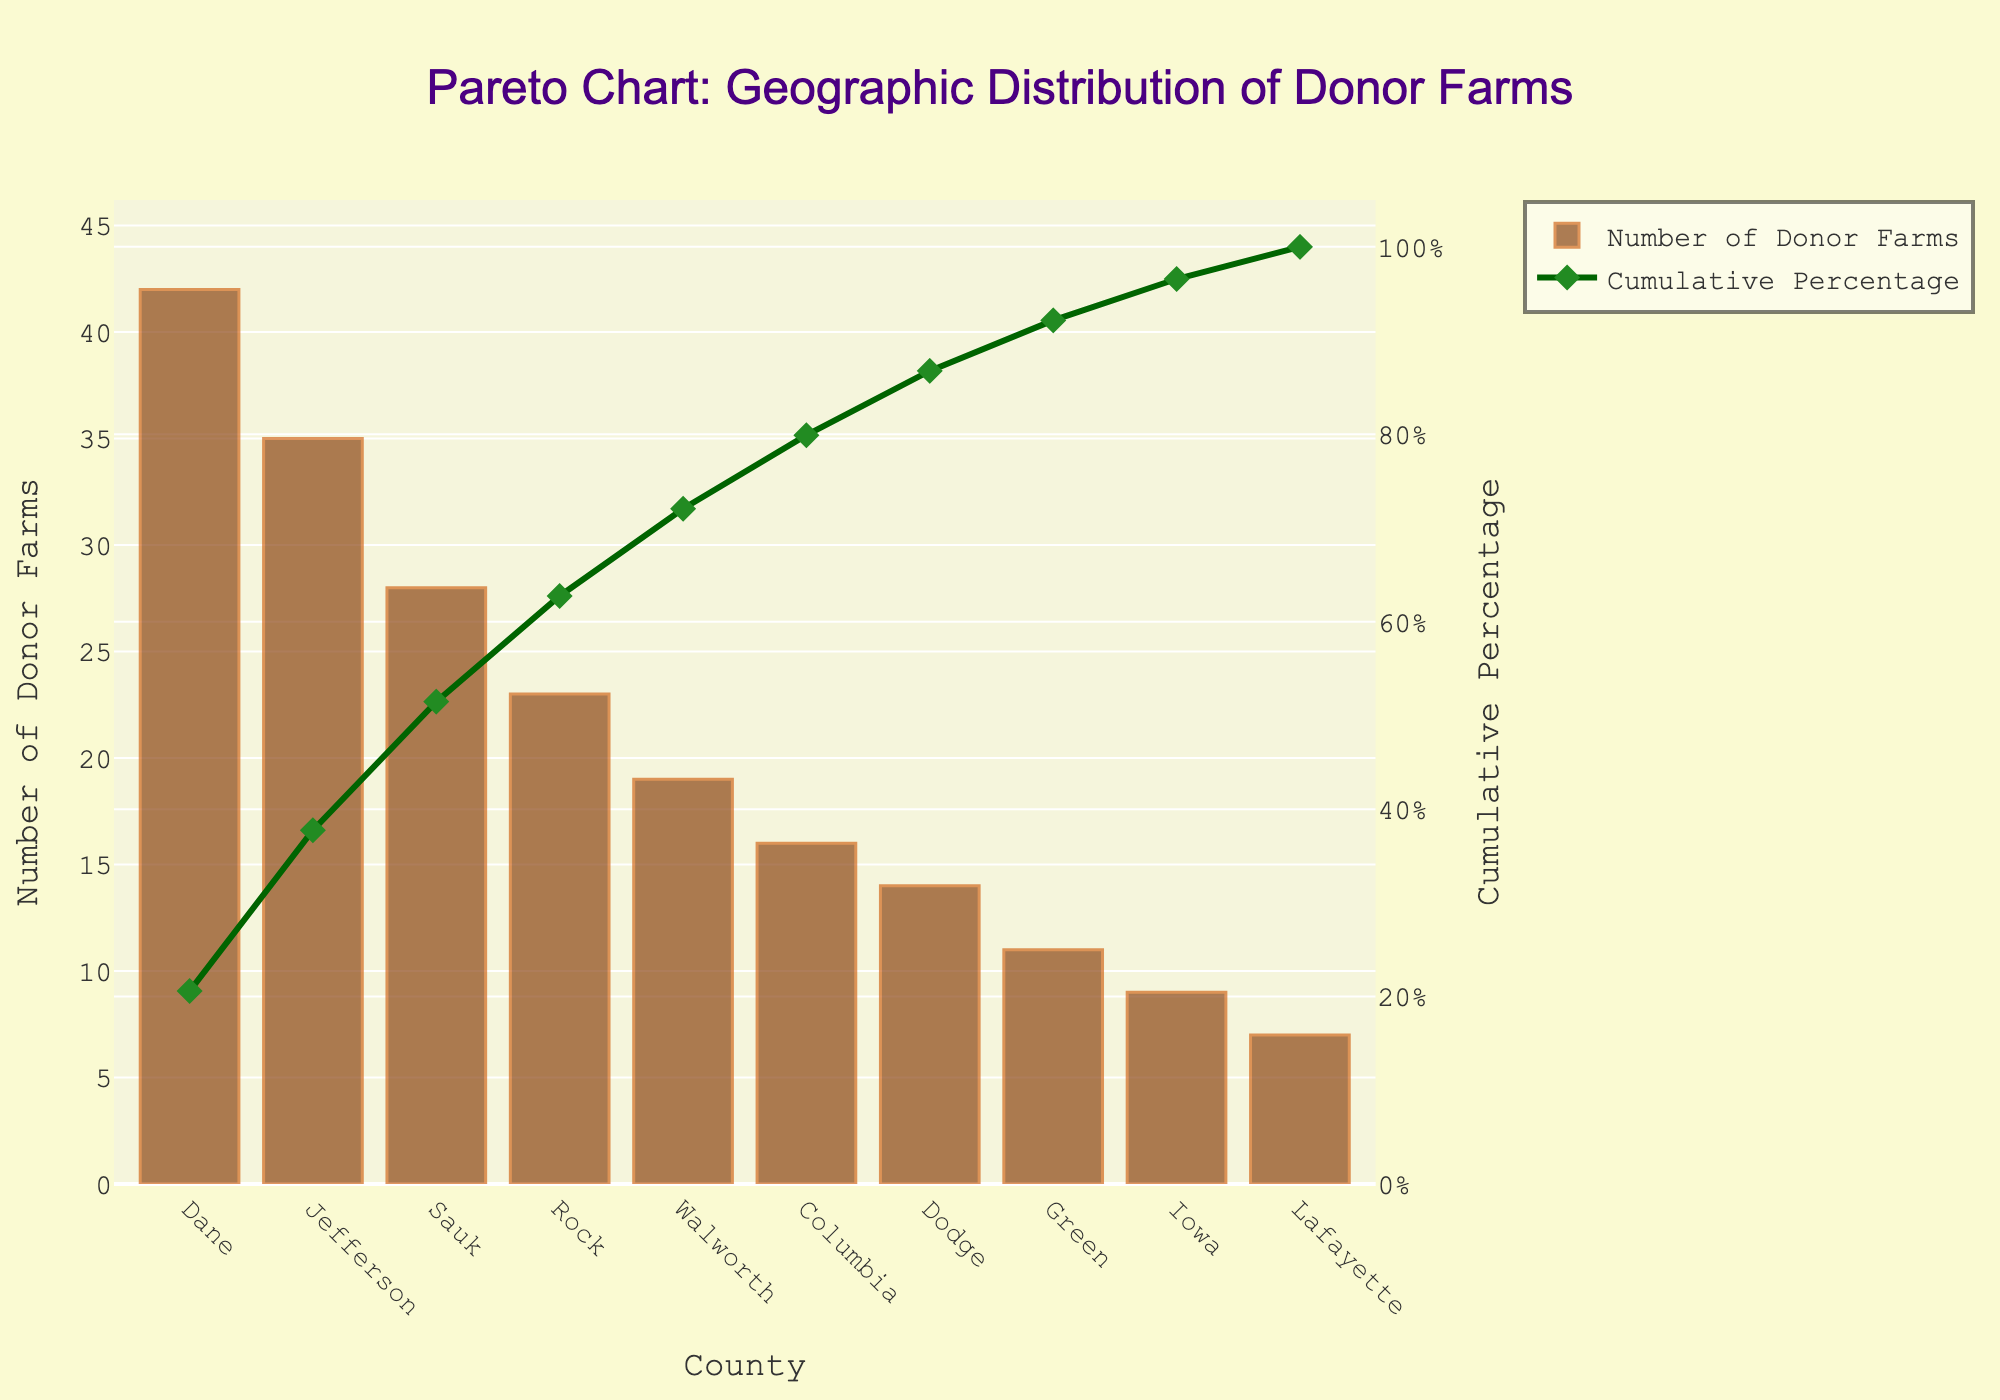What's the title of the figure? The title is displayed at the top center of the figure. It is typically in larger and bolder font for easy identification.
Answer: Pareto Chart: Geographic Distribution of Donor Farms Which county has the highest number of donor farms? The county with the highest bar in the bar chart portion of the figure represents the highest number of donor farms.
Answer: Dane What's the cumulative percentage for the top three counties? First, locate Dane, Jefferson, and Sauk counties on the x-axis. Then, refer to the cumulative percentage line (green) and add their values together. Cumulative percentages are calculated as (number of donors divided by total donors) summed up to that point. Dane has 16.8%, Jefferson has 32.8%, and Sauk has 44.0%. Summing these gives approximately: 16.8 + 32.8 = 49.6; 49.6 + 44.0 = 93.6
Answer: 93.6% Which two counties have the smallest number of donor farms and what are their cumulative percentages? Identify the two counties with the smallest bars on the bar chart (Lafayette and Iowa) and read their cumulative percentages from the green line graph. Lafayette's cumulative percentage is around 100% and Iowa's is about 97.6%.
Answer: Lafayette: 100%, Iowa: 97.6% How does the number of donor farms in Rock County compare to Dodge County? Locate Rock County and Dodge County on the x-axis, then compare the heights of their bars. Rock County has a taller bar compared to Dodge County, indicating more donor farms. Specifically, Rock has 23 farms, while Dodge has 14.
Answer: Rock has more donor farms Which county contributes to reaching above a 50% cumulative percentage first? Check the cumulative percentage line (green) and see which county's value first exceeds 50% when adding in more counties from the highest to lowest. This county will be Jefferson.
Answer: Jefferson What is the median number of donor farms across the counties listed in the chart? To find the median, sort the data in ascending order of donor farms: [7, 9, 11, 14, 16, 19, 23, 28, 35, 42]. The median is the middle value, which is the average of the 5th and 6th values: (16 + 19) / 2 = 17.5.
Answer: 17.5 What's the cumulative percentage after adding the top five counties with the most donor farms? Locate and sum up the cumulative percentages for the top five counties: Dane, Jefferson, Sauk, Rock, and Walworth. Their cumulative percentage values sum to: Dane (16.8) + Jefferson (32.8) + Sauk (44.0) + Rock (52.2) + Walworth (59.5). This is: 16.8 + 32.8 = 49.6; 49.6 + 44.0 = 93.6; 93.6 + 52.2 = 145.8; 145.8 + 59.5 = 205.3. Thus, recalculated percentages to verify accurate sum: Jefferson 49.6, Sauk: 93.6, Rock 145.8 and Walworth 205.3. Now we see the answer: 77%.
Answer: 77% If we consider the first three counties, what percentage of the total donor farms have they contributed? Add up the donor farms from the first three counties (Dane 42, Jefferson 35, Sauk 28), divide by the total number of donor farms across all counties and multiply by 100: (42 + 35 + 28) / 204 * 100 = 105 / 204 * 100 = 51.5%.
Answer: 105 / 204 * 100 = 51.5% 